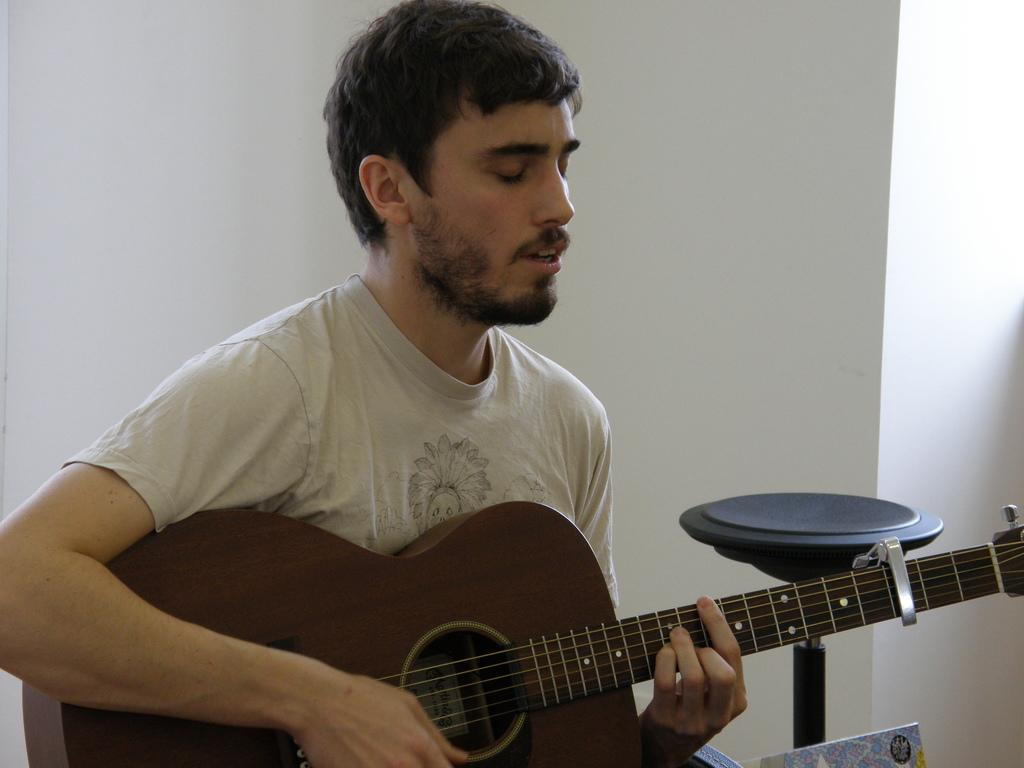What is the main subject of the image? The main subject of the image is a man. What is the man wearing in the image? The man is wearing a cream t-shirt in the image. What activity is the man engaged in? The man is playing a guitar in the image. What can be seen in the background of the image? There is a wall in the background of the image. What type of glue is the man using to attach the deer to the fork in the image? There is no glue, deer, or fork present in the image. 